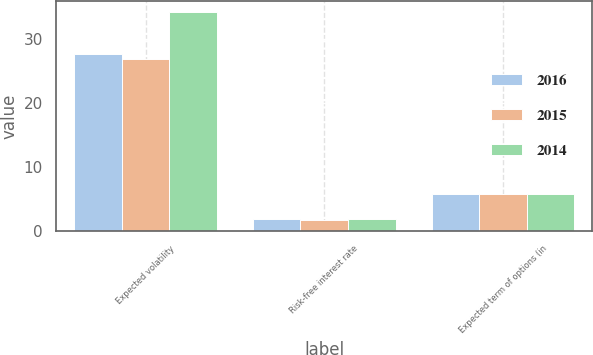<chart> <loc_0><loc_0><loc_500><loc_500><stacked_bar_chart><ecel><fcel>Expected volatility<fcel>Risk-free interest rate<fcel>Expected term of options (in<nl><fcel>2016<fcel>27.77<fcel>1.82<fcel>5.82<nl><fcel>2015<fcel>27<fcel>1.67<fcel>5.82<nl><fcel>2014<fcel>34.25<fcel>1.79<fcel>5.82<nl></chart> 